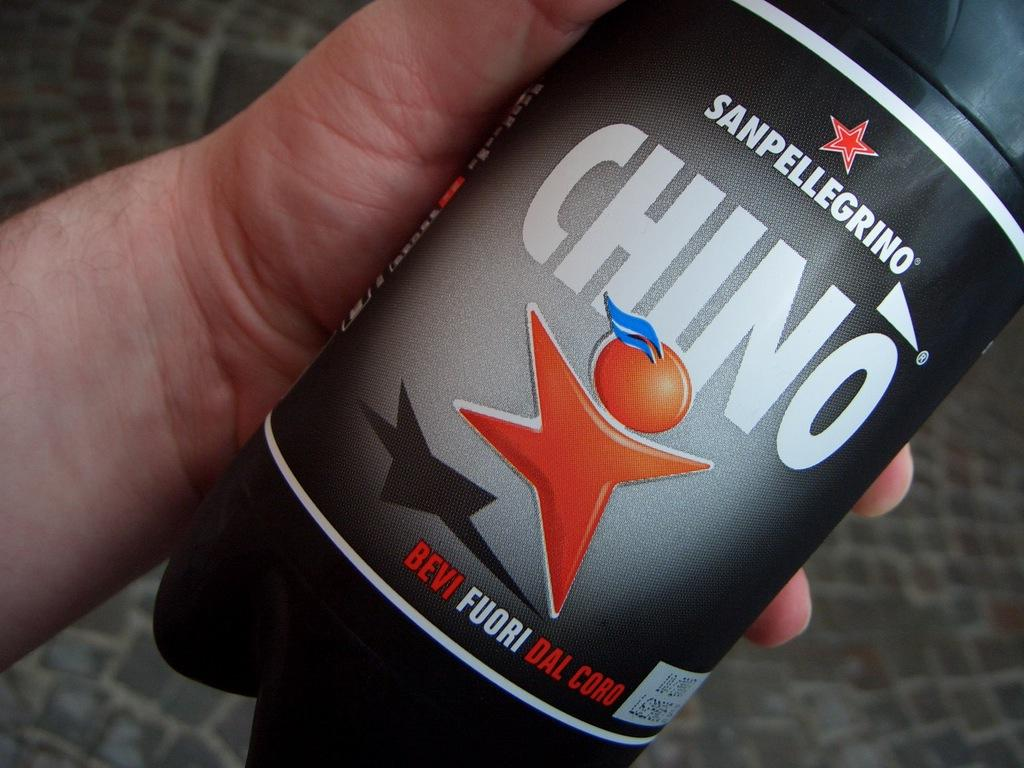<image>
Provide a brief description of the given image. A can of Sanpellegrino Chino is held in a person's hand. 